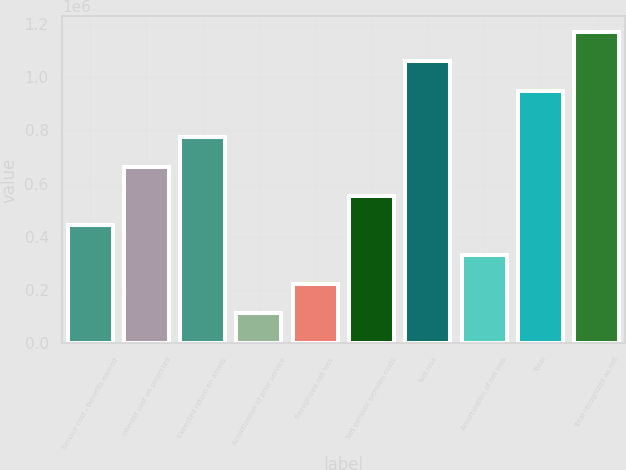Convert chart to OTSL. <chart><loc_0><loc_0><loc_500><loc_500><bar_chart><fcel>Service cost - benefits earned<fcel>Interest cost on projected<fcel>Expected return on assets<fcel>Amortization of prior service<fcel>Recognized net loss<fcel>Net periodic pension costs<fcel>Net loss<fcel>Amortization of net loss<fcel>Total<fcel>Total recognized as net<nl><fcel>442960<fcel>663074<fcel>773131<fcel>112790<fcel>222847<fcel>553017<fcel>1.05935e+06<fcel>332903<fcel>949297<fcel>1.16941e+06<nl></chart> 